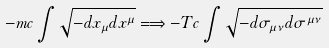Convert formula to latex. <formula><loc_0><loc_0><loc_500><loc_500>- m c \int \sqrt { - d x _ { \mu } d x ^ { \mu } } \Longrightarrow - T c \int \sqrt { - d \sigma _ { \mu \nu } d \sigma ^ { \mu \nu } }</formula> 